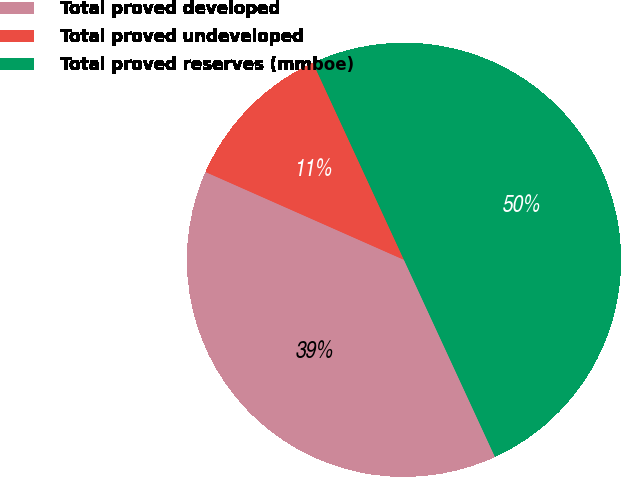<chart> <loc_0><loc_0><loc_500><loc_500><pie_chart><fcel>Total proved developed<fcel>Total proved undeveloped<fcel>Total proved reserves (mmboe)<nl><fcel>38.52%<fcel>11.48%<fcel>50.0%<nl></chart> 